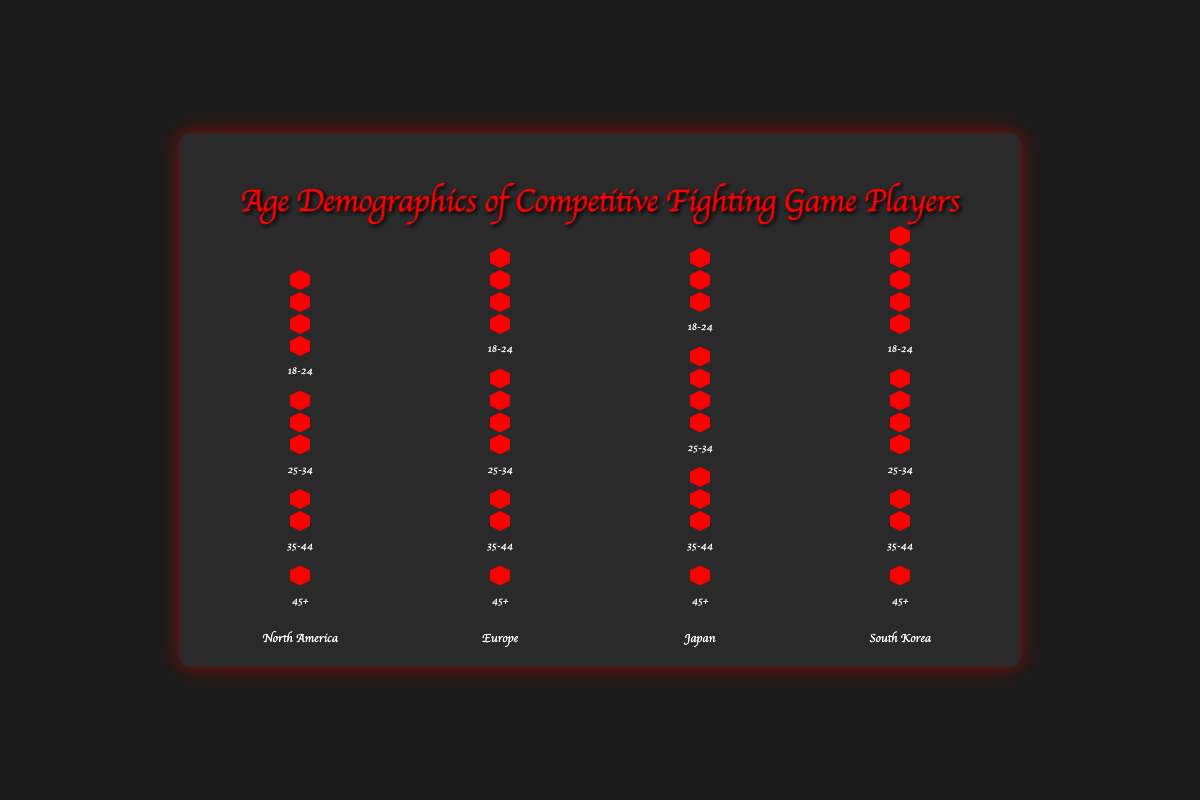What region has the highest count of players in the 18-24 age group? Look at the 18-24 age group across all regions and identify the region with the tallest bar or most icons. The region with the highest count of players in the 18-24 age group is South Korea, with 45 players represented by five icons.
Answer: South Korea Which age group has the lowest representation in Japan? Examine each age group's bar in the Japan section to find the age range with the shortest bar or least number of icons. The shortest bar is the 45+ age group with only one icon, which translates to 5 players.
Answer: 45+ What is the total count of players aged 25-34 in North America and Europe combined? Add the counts of players aged 25-34 in both regions. North America has 30 players and Europe has 35 players in this age group. The combined total is 30 + 35 = 65.
Answer: 65 Which region has equal counts of players aged 18-24 and 25-34? Compare the counts of players in the age groups 18-24 and 25-34 for each region. Europe has 35 players in both the 18-24 and 25-34 age groups, making them equal.
Answer: Europe How many more players aged 18-24 are there in South Korea compared to Japan? Subtract the count of players aged 18-24 in Japan from those in South Korea. South Korea has 45 players, while Japan has 30 players in this age range, so the difference is 45 - 30 = 15.
Answer: 15 What is the average count of players in the 35-44 age group across all regions? Add the counts of players in the 35-44 age group from each region and divide by the number of regions. The counts are 20 (North America) + 20 (Europe) + 25 (Japan) + 15 (South Korea) = 80. There are 4 regions, so the average is 80 / 4 = 20.
Answer: 20 Which region has the least representation in the 25-34 age group? Identify the region with the shortest bar in the 25-34 age group. North America has the shortest bar with 30 players.
Answer: North America How many more players are there in the 18-24 age group compared to the 45+ age group in North America? Subtract the count of players in the 45+ age group from those in the 18-24 age group in North America. The 18-24 group has 40 players and the 45+ group has 10 players, so the difference is 40 - 10 = 30.
Answer: 30 